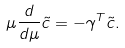<formula> <loc_0><loc_0><loc_500><loc_500>\mu \frac { d } { d \mu } { \tilde { c } } = - \gamma ^ { T } { \tilde { c } } .</formula> 